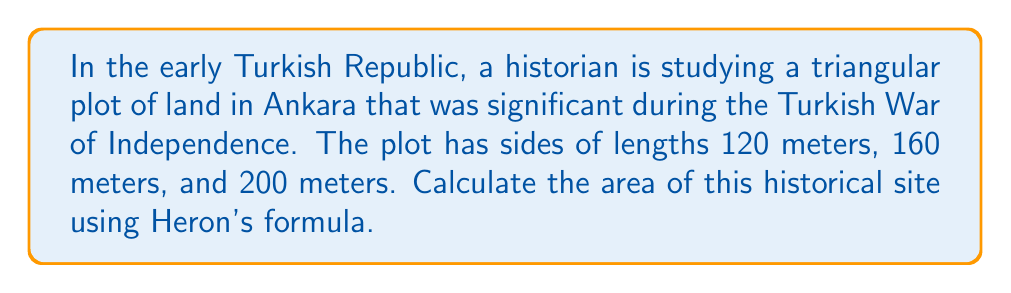Solve this math problem. To solve this problem, we'll use Heron's formula, which calculates the area of a triangle given the lengths of its three sides.

1. Let's define our sides:
   $a = 120$ m, $b = 160$ m, $c = 200$ m

2. Heron's formula states that the area $A$ of a triangle with sides $a$, $b$, and $c$ is:
   $$ A = \sqrt{s(s-a)(s-b)(s-c)} $$
   where $s$ is the semi-perimeter of the triangle.

3. Calculate the semi-perimeter $s$:
   $$ s = \frac{a + b + c}{2} = \frac{120 + 160 + 200}{2} = \frac{480}{2} = 240 \text{ m} $$

4. Now, let's substitute these values into Heron's formula:
   $$ A = \sqrt{240(240-120)(240-160)(240-200)} $$
   $$ A = \sqrt{240 \cdot 120 \cdot 80 \cdot 40} $$

5. Simplify under the square root:
   $$ A = \sqrt{9,216,000} $$

6. Calculate the square root:
   $$ A = 3,036 \text{ m}^2 $$

Thus, the area of the historical triangular plot is 3,036 square meters.
Answer: $3,036 \text{ m}^2$ 